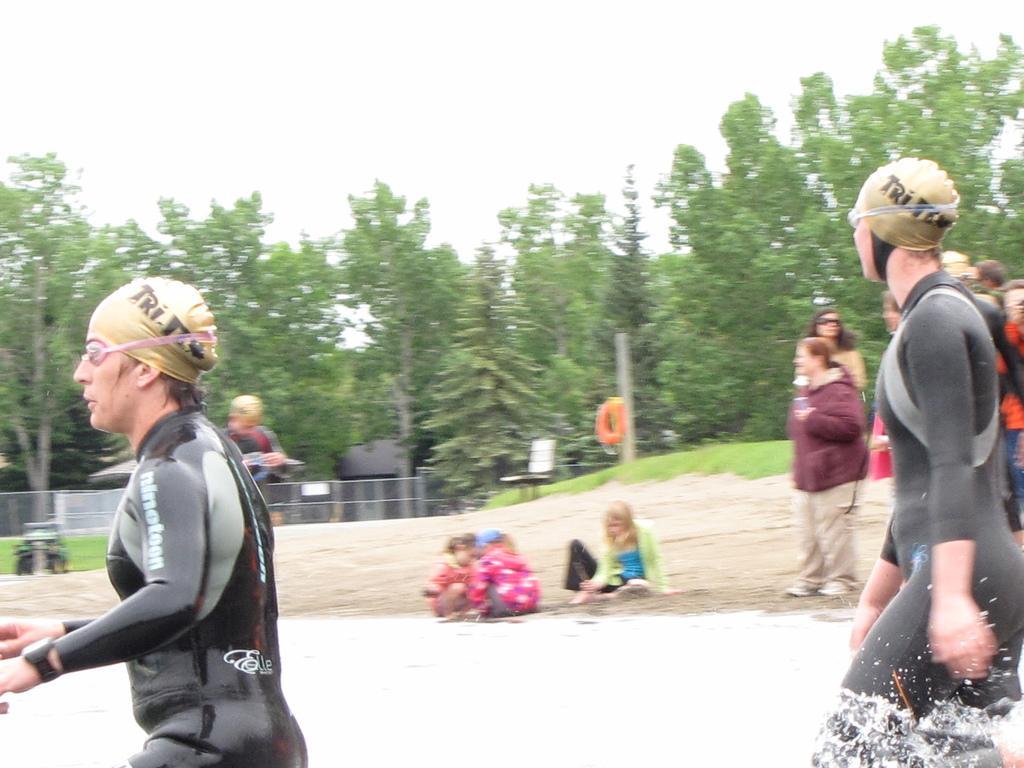Describe this image in one or two sentences. In this image there are persons in the water in the front wearing a swimsuit. In the background there a persons sitting and standing and there are trees, there is grass on the ground and the sky is cloudy. 